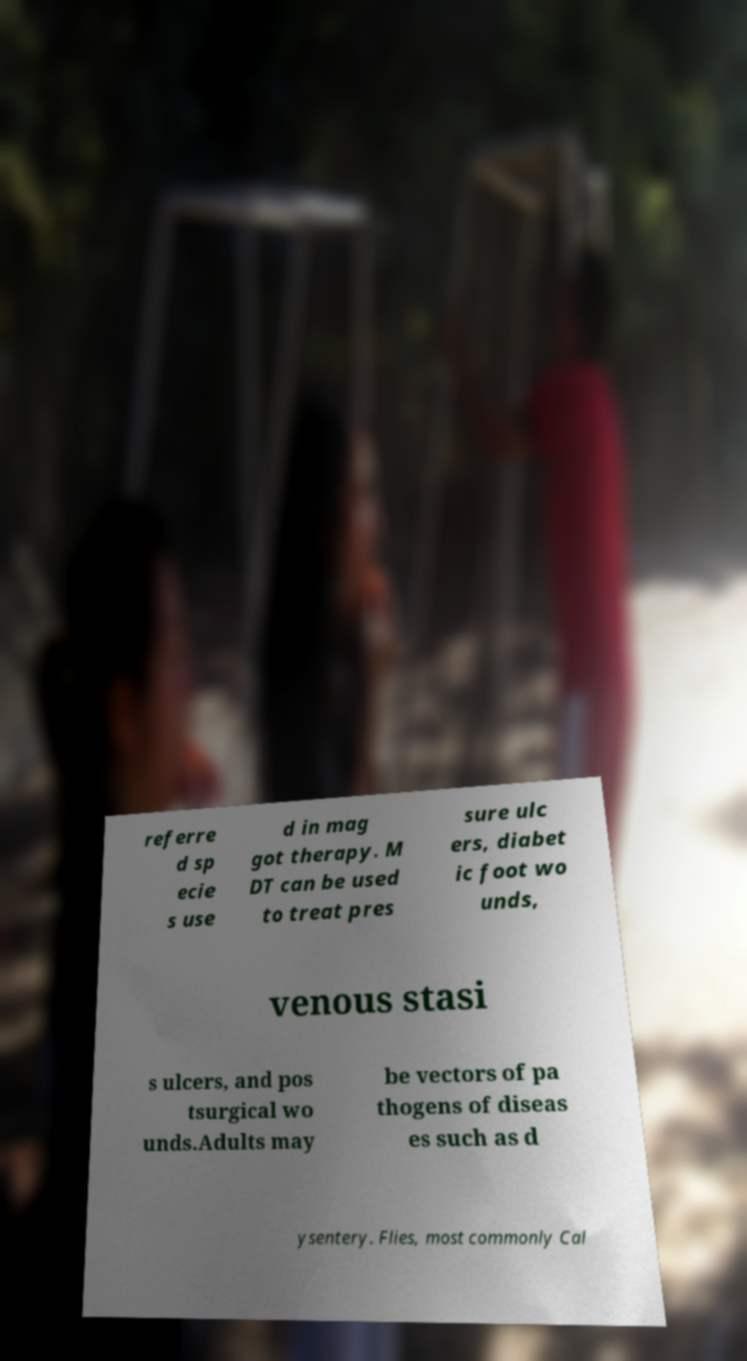Please identify and transcribe the text found in this image. referre d sp ecie s use d in mag got therapy. M DT can be used to treat pres sure ulc ers, diabet ic foot wo unds, venous stasi s ulcers, and pos tsurgical wo unds.Adults may be vectors of pa thogens of diseas es such as d ysentery. Flies, most commonly Cal 